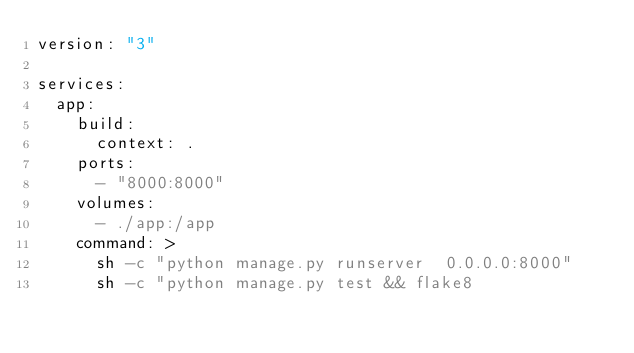Convert code to text. <code><loc_0><loc_0><loc_500><loc_500><_YAML_>version: "3"

services:
  app:
    build:
      context: .
    ports:
      - "8000:8000"
    volumes:
      - ./app:/app
    command: >
      sh -c "python manage.py runserver  0.0.0.0:8000"
      sh -c "python manage.py test && flake8</code> 